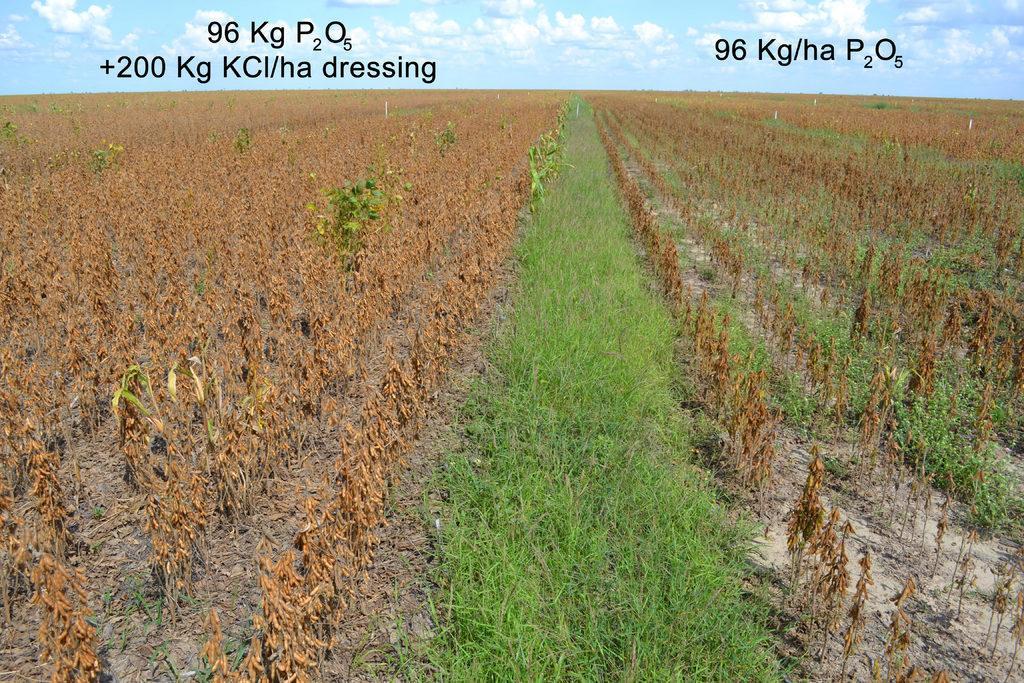How would you summarize this image in a sentence or two? On the left side these are the dried plants, in the middle this is the green grass. At the top it's a sunny sky. 